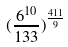Convert formula to latex. <formula><loc_0><loc_0><loc_500><loc_500>( \frac { 6 ^ { 1 0 } } { 1 3 3 } ) ^ { \frac { 4 1 1 } { 9 } }</formula> 